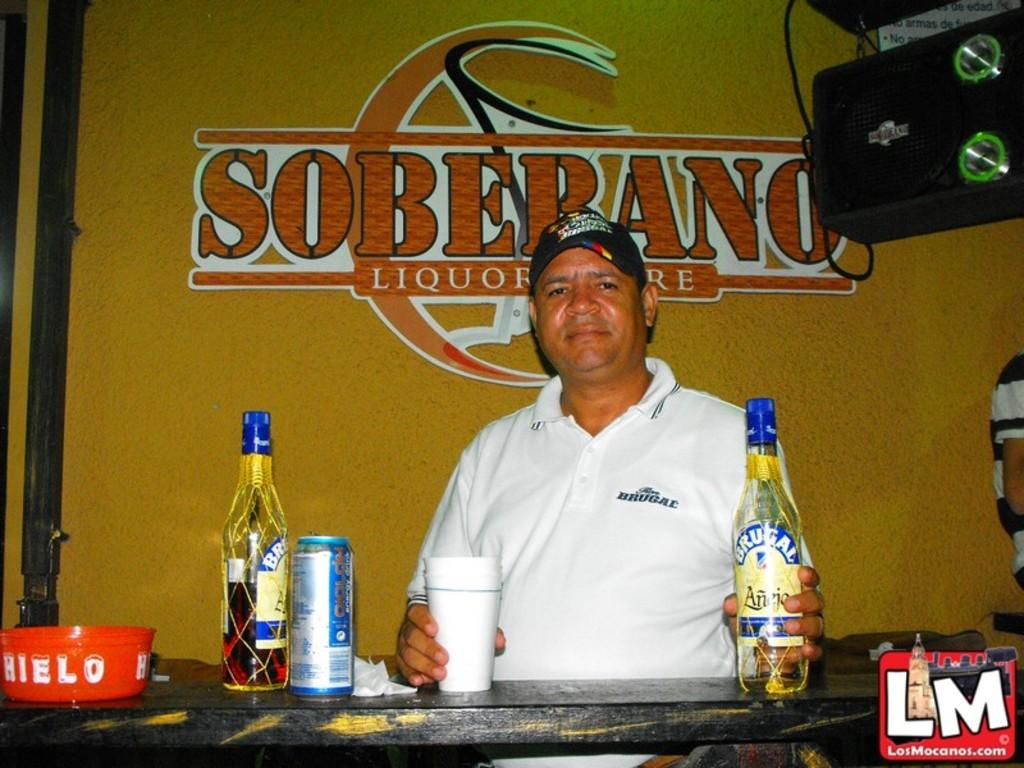Provide a one-sentence caption for the provided image. A man in a white shirt is seated before a Soberano alcohol advertisement. 